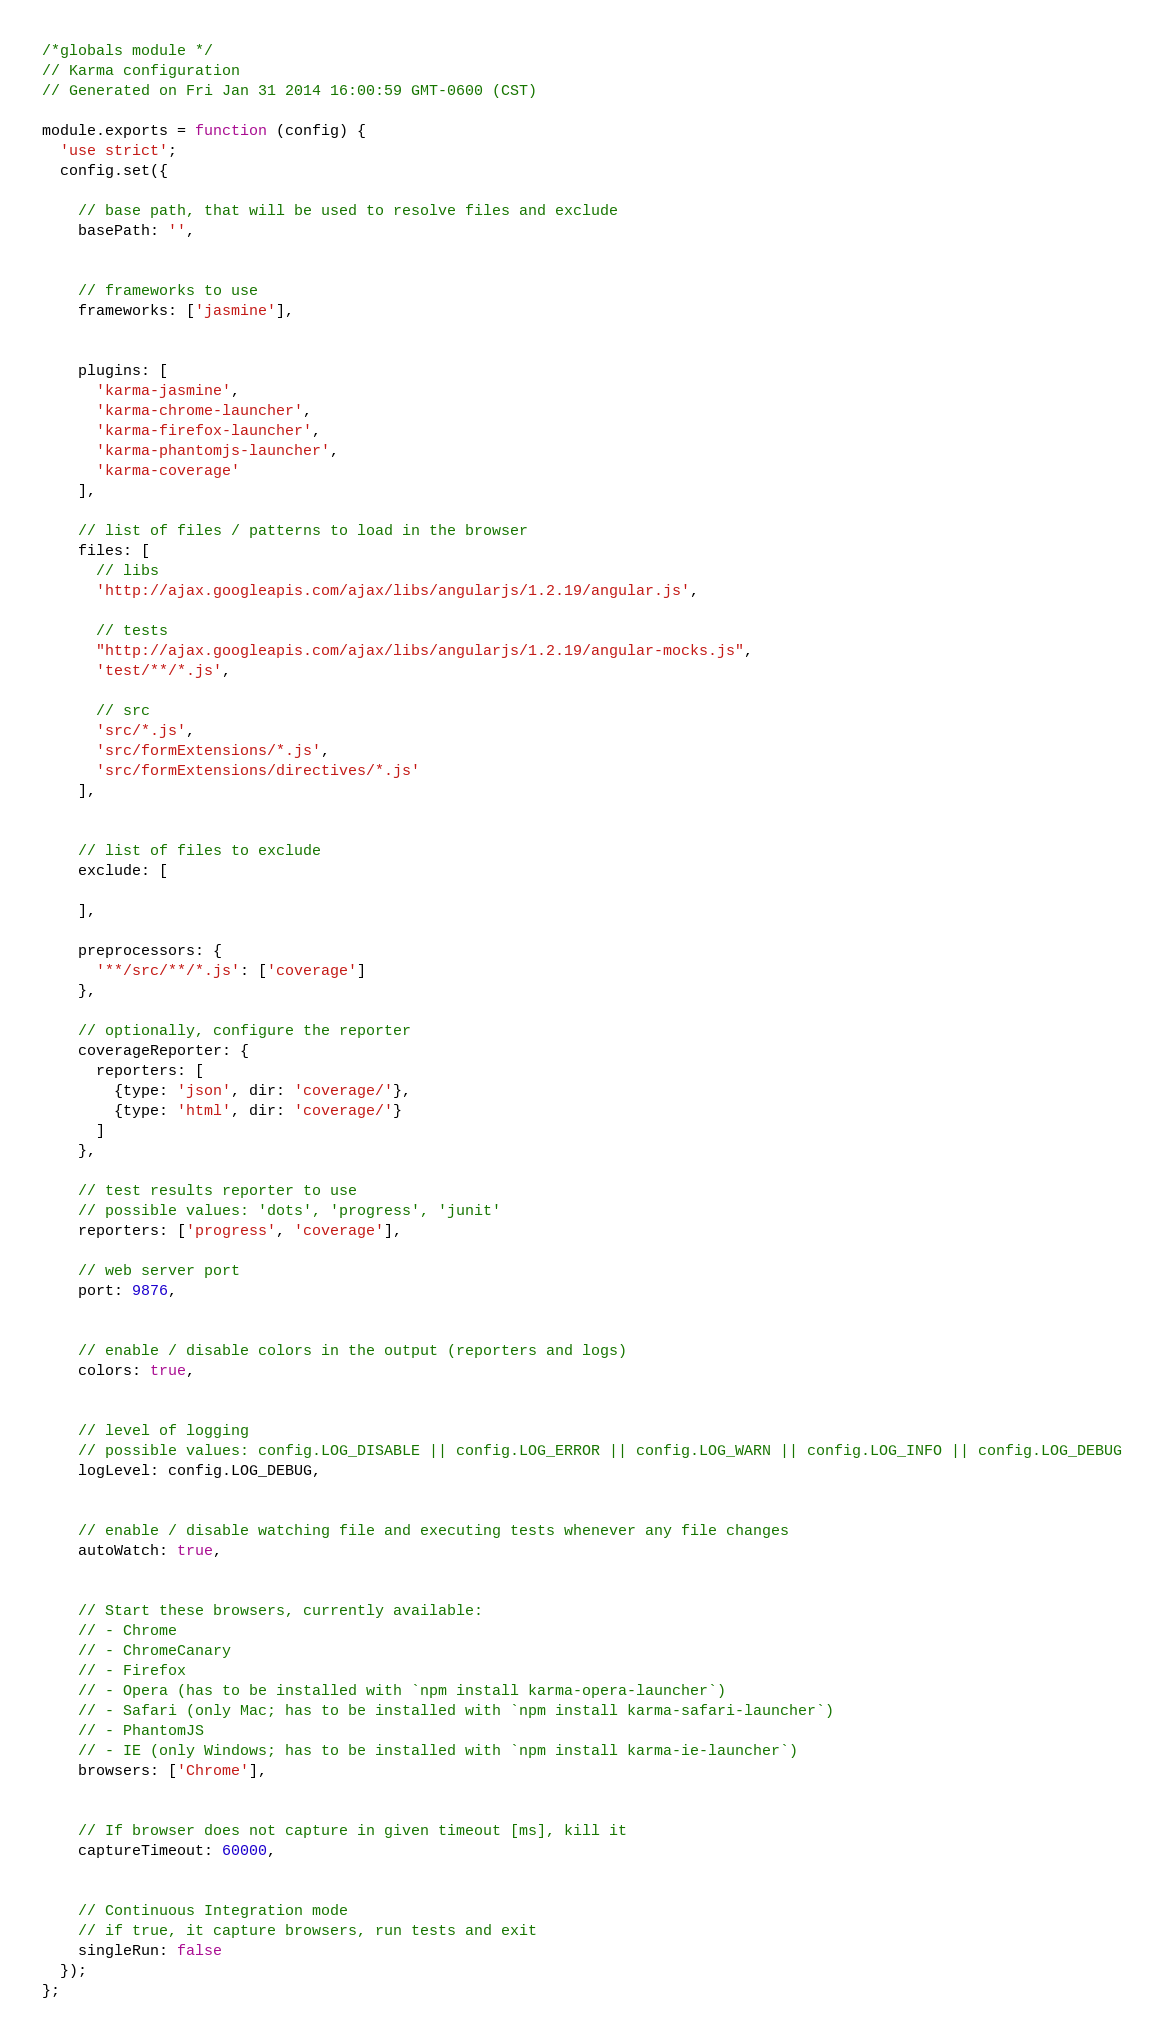Convert code to text. <code><loc_0><loc_0><loc_500><loc_500><_JavaScript_>/*globals module */
// Karma configuration
// Generated on Fri Jan 31 2014 16:00:59 GMT-0600 (CST)

module.exports = function (config) {
  'use strict';
  config.set({

    // base path, that will be used to resolve files and exclude
    basePath: '',


    // frameworks to use
    frameworks: ['jasmine'],


    plugins: [
      'karma-jasmine',
      'karma-chrome-launcher',
      'karma-firefox-launcher',
      'karma-phantomjs-launcher',
      'karma-coverage'
    ],

    // list of files / patterns to load in the browser
    files: [
      // libs
      'http://ajax.googleapis.com/ajax/libs/angularjs/1.2.19/angular.js',

      // tests
      "http://ajax.googleapis.com/ajax/libs/angularjs/1.2.19/angular-mocks.js",
      'test/**/*.js',

      // src
      'src/*.js',
      'src/formExtensions/*.js',
      'src/formExtensions/directives/*.js'
    ],


    // list of files to exclude
    exclude: [

    ],

    preprocessors: {
      '**/src/**/*.js': ['coverage']
    },

    // optionally, configure the reporter
    coverageReporter: {
      reporters: [
        {type: 'json', dir: 'coverage/'},
        {type: 'html', dir: 'coverage/'}
      ]
    },

    // test results reporter to use
    // possible values: 'dots', 'progress', 'junit'
    reporters: ['progress', 'coverage'],

    // web server port
    port: 9876,


    // enable / disable colors in the output (reporters and logs)
    colors: true,


    // level of logging
    // possible values: config.LOG_DISABLE || config.LOG_ERROR || config.LOG_WARN || config.LOG_INFO || config.LOG_DEBUG
    logLevel: config.LOG_DEBUG,


    // enable / disable watching file and executing tests whenever any file changes
    autoWatch: true,


    // Start these browsers, currently available:
    // - Chrome
    // - ChromeCanary
    // - Firefox
    // - Opera (has to be installed with `npm install karma-opera-launcher`)
    // - Safari (only Mac; has to be installed with `npm install karma-safari-launcher`)
    // - PhantomJS
    // - IE (only Windows; has to be installed with `npm install karma-ie-launcher`)
    browsers: ['Chrome'],


    // If browser does not capture in given timeout [ms], kill it
    captureTimeout: 60000,


    // Continuous Integration mode
    // if true, it capture browsers, run tests and exit
    singleRun: false
  });
};
</code> 